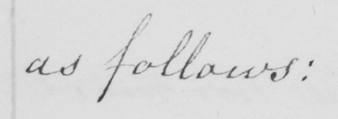Please provide the text content of this handwritten line. as follows : 